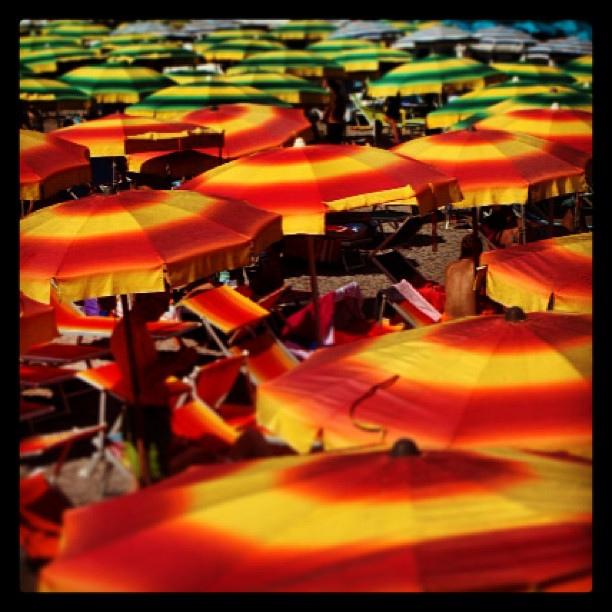What are the same color of all the umbrellas?
Short answer required. Yellow. Are all the umbrellas the same color?
Write a very short answer. No. What color are the closest umbrellas?
Be succinct. Red and yellow. 